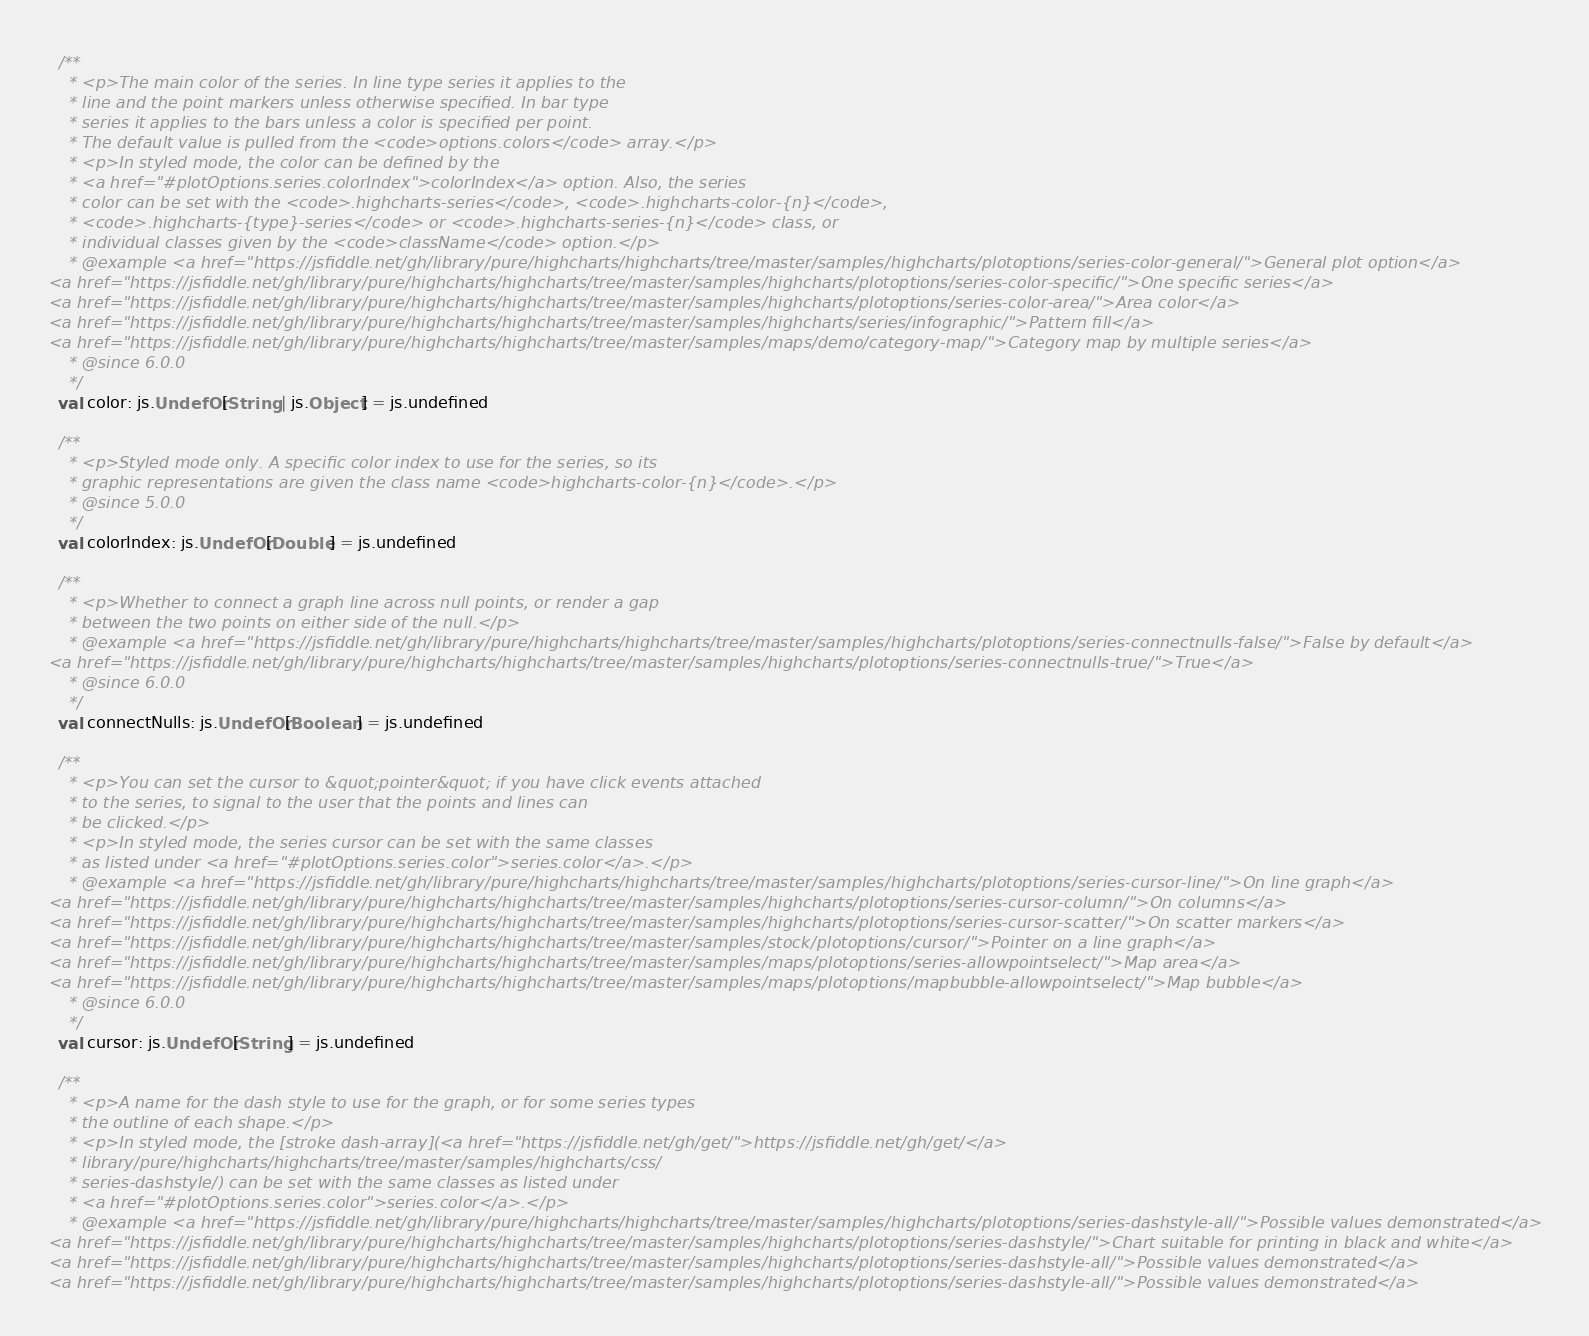<code> <loc_0><loc_0><loc_500><loc_500><_Scala_>  /**
    * <p>The main color of the series. In line type series it applies to the
    * line and the point markers unless otherwise specified. In bar type
    * series it applies to the bars unless a color is specified per point.
    * The default value is pulled from the <code>options.colors</code> array.</p>
    * <p>In styled mode, the color can be defined by the
    * <a href="#plotOptions.series.colorIndex">colorIndex</a> option. Also, the series
    * color can be set with the <code>.highcharts-series</code>, <code>.highcharts-color-{n}</code>,
    * <code>.highcharts-{type}-series</code> or <code>.highcharts-series-{n}</code> class, or
    * individual classes given by the <code>className</code> option.</p>
    * @example <a href="https://jsfiddle.net/gh/library/pure/highcharts/highcharts/tree/master/samples/highcharts/plotoptions/series-color-general/">General plot option</a>
<a href="https://jsfiddle.net/gh/library/pure/highcharts/highcharts/tree/master/samples/highcharts/plotoptions/series-color-specific/">One specific series</a>
<a href="https://jsfiddle.net/gh/library/pure/highcharts/highcharts/tree/master/samples/highcharts/plotoptions/series-color-area/">Area color</a>
<a href="https://jsfiddle.net/gh/library/pure/highcharts/highcharts/tree/master/samples/highcharts/series/infographic/">Pattern fill</a>
<a href="https://jsfiddle.net/gh/library/pure/highcharts/highcharts/tree/master/samples/maps/demo/category-map/">Category map by multiple series</a>
    * @since 6.0.0
    */
  val color: js.UndefOr[String | js.Object] = js.undefined

  /**
    * <p>Styled mode only. A specific color index to use for the series, so its
    * graphic representations are given the class name <code>highcharts-color-{n}</code>.</p>
    * @since 5.0.0
    */
  val colorIndex: js.UndefOr[Double] = js.undefined

  /**
    * <p>Whether to connect a graph line across null points, or render a gap
    * between the two points on either side of the null.</p>
    * @example <a href="https://jsfiddle.net/gh/library/pure/highcharts/highcharts/tree/master/samples/highcharts/plotoptions/series-connectnulls-false/">False by default</a>
<a href="https://jsfiddle.net/gh/library/pure/highcharts/highcharts/tree/master/samples/highcharts/plotoptions/series-connectnulls-true/">True</a>
    * @since 6.0.0
    */
  val connectNulls: js.UndefOr[Boolean] = js.undefined

  /**
    * <p>You can set the cursor to &quot;pointer&quot; if you have click events attached
    * to the series, to signal to the user that the points and lines can
    * be clicked.</p>
    * <p>In styled mode, the series cursor can be set with the same classes
    * as listed under <a href="#plotOptions.series.color">series.color</a>.</p>
    * @example <a href="https://jsfiddle.net/gh/library/pure/highcharts/highcharts/tree/master/samples/highcharts/plotoptions/series-cursor-line/">On line graph</a>
<a href="https://jsfiddle.net/gh/library/pure/highcharts/highcharts/tree/master/samples/highcharts/plotoptions/series-cursor-column/">On columns</a>
<a href="https://jsfiddle.net/gh/library/pure/highcharts/highcharts/tree/master/samples/highcharts/plotoptions/series-cursor-scatter/">On scatter markers</a>
<a href="https://jsfiddle.net/gh/library/pure/highcharts/highcharts/tree/master/samples/stock/plotoptions/cursor/">Pointer on a line graph</a>
<a href="https://jsfiddle.net/gh/library/pure/highcharts/highcharts/tree/master/samples/maps/plotoptions/series-allowpointselect/">Map area</a>
<a href="https://jsfiddle.net/gh/library/pure/highcharts/highcharts/tree/master/samples/maps/plotoptions/mapbubble-allowpointselect/">Map bubble</a>
    * @since 6.0.0
    */
  val cursor: js.UndefOr[String] = js.undefined

  /**
    * <p>A name for the dash style to use for the graph, or for some series types
    * the outline of each shape.</p>
    * <p>In styled mode, the [stroke dash-array](<a href="https://jsfiddle.net/gh/get/">https://jsfiddle.net/gh/get/</a>
    * library/pure/highcharts/highcharts/tree/master/samples/highcharts/css/
    * series-dashstyle/) can be set with the same classes as listed under
    * <a href="#plotOptions.series.color">series.color</a>.</p>
    * @example <a href="https://jsfiddle.net/gh/library/pure/highcharts/highcharts/tree/master/samples/highcharts/plotoptions/series-dashstyle-all/">Possible values demonstrated</a>
<a href="https://jsfiddle.net/gh/library/pure/highcharts/highcharts/tree/master/samples/highcharts/plotoptions/series-dashstyle/">Chart suitable for printing in black and white</a>
<a href="https://jsfiddle.net/gh/library/pure/highcharts/highcharts/tree/master/samples/highcharts/plotoptions/series-dashstyle-all/">Possible values demonstrated</a>
<a href="https://jsfiddle.net/gh/library/pure/highcharts/highcharts/tree/master/samples/highcharts/plotoptions/series-dashstyle-all/">Possible values demonstrated</a></code> 